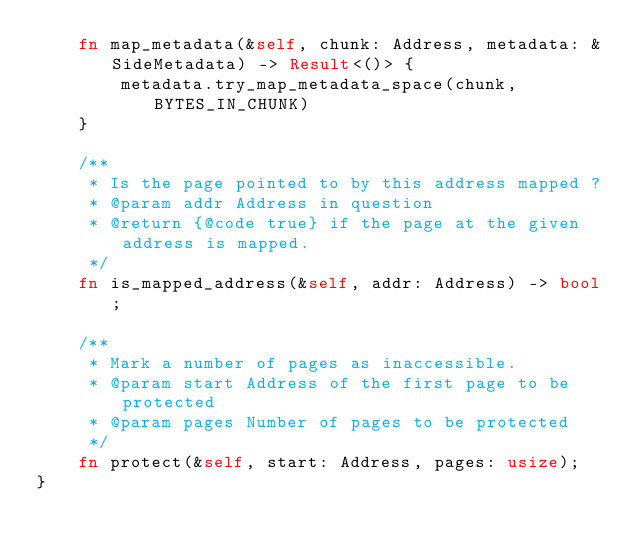<code> <loc_0><loc_0><loc_500><loc_500><_Rust_>    fn map_metadata(&self, chunk: Address, metadata: &SideMetadata) -> Result<()> {
        metadata.try_map_metadata_space(chunk, BYTES_IN_CHUNK)
    }

    /**
     * Is the page pointed to by this address mapped ?
     * @param addr Address in question
     * @return {@code true} if the page at the given address is mapped.
     */
    fn is_mapped_address(&self, addr: Address) -> bool;

    /**
     * Mark a number of pages as inaccessible.
     * @param start Address of the first page to be protected
     * @param pages Number of pages to be protected
     */
    fn protect(&self, start: Address, pages: usize);
}
</code> 